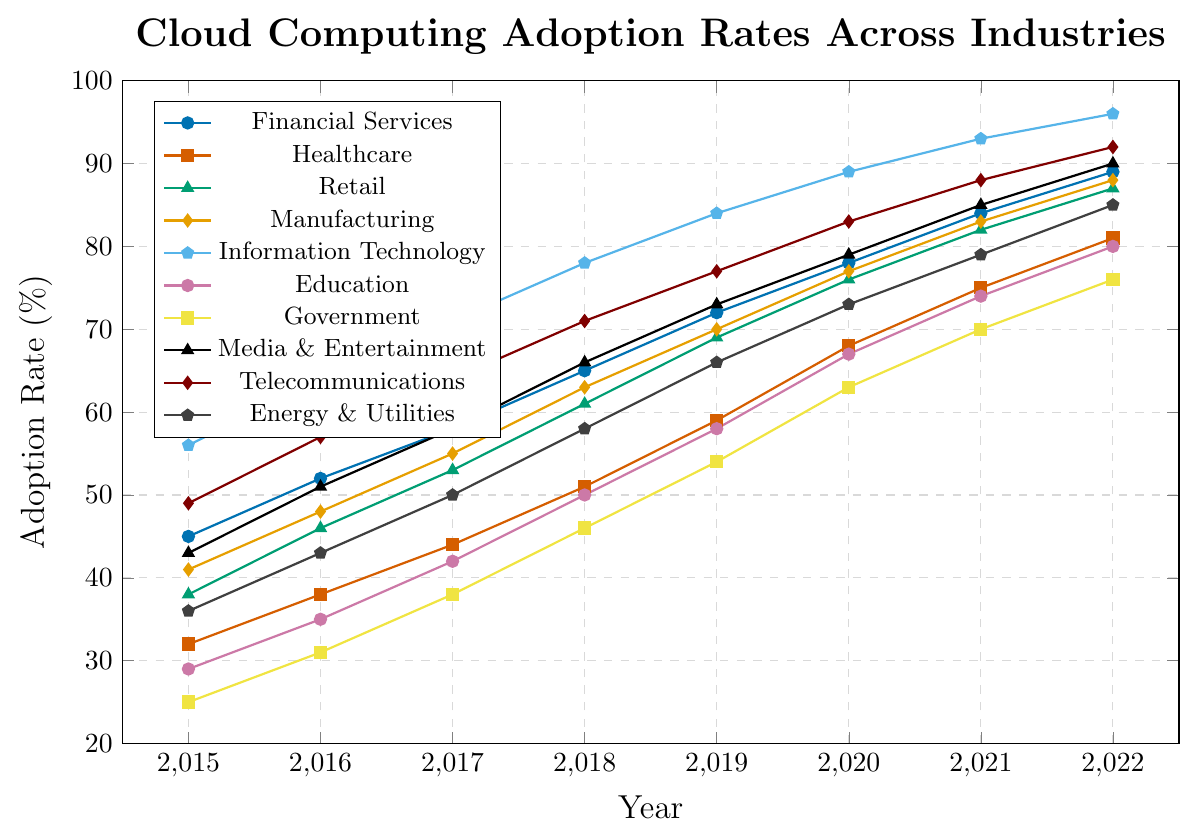Which industry had the highest cloud computing adoption rate in 2022? By looking at the graph and identifying the highest point on the y-axis for the year 2022, we can see that Information Technology has the highest adoption rate.
Answer: Information Technology What was the adoption rate increase in the Healthcare industry from 2015 to 2022? Subtract the adoption rate in 2015 from the adoption rate in 2022: 81 - 32 = 49.
Answer: 49% Between 2016 and 2018, which industry showed the largest increase in adoption rate? To find the industry with the largest increase, we need to calculate the increase for each industry between 2016 and 2018:
- Financial Services: 65 - 52 = 13 
- Healthcare: 51 - 38 = 13
- Retail: 61 - 46 = 15
- Manufacturing: 63 - 48 = 15
- Information Technology: 78 - 64 = 14
- Education: 50 - 35 = 15
- Government: 46 - 31 = 15
- Media & Entertainment: 66 - 51 = 15
- Telecommunications: 71 - 57 = 14
- Energy & Utilities: 58 - 43 = 15
Retail, Manufacturing, Education, Government, Media & Entertainment, and Energy & Utilities all had the largest increase of 15%.
Answer: Retail, Manufacturing, Education, Government, Media & Entertainment, Energy & Utilities Which industry had the lowest adoption rate in 2015 and what was the rate? By looking at the values for 2015, the Government industry had the lowest adoption rate.
Answer: 25% How does the adoption rate of Media & Entertainment in 2020 compare to that of Telecommunications in 2020? By comparing the values for both industries in 2020 from the graph, Media & Entertainment had an adoption rate of 79%, while Telecommunications had an adoption rate of 83%. Thus, Telecommunications had a higher adoption rate.
Answer: Telecommunications was higher What is the average adoption rate of Information Technology from 2015 to 2022? Sum the adoption rates for each year for Information Technology and divide by the number of years: (56 + 64 + 71 + 78 + 84 + 89 + 93 + 96) / 8 = 78.875.
Answer: 78.875% Which industry had the smallest variation in adoption rates from 2015 to 2022? Calculate the range (max - min) for each industry and find the smallest:
- Financial Services: 89 - 45 = 44
- Healthcare: 81 - 32 = 49
- Retail: 87 - 38 = 49
- Manufacturing: 88 - 41 = 47
- Information Technology: 96 - 56 = 40
- Education: 80 - 29 = 51
- Government: 76 - 25 = 51
- Media & Entertainment: 90 - 43 = 47
- Telecommunications: 92 - 49 = 43
- Energy & Utilities: 85 - 36 = 49
Information Technology has the smallest range.
Answer: Information Technology 